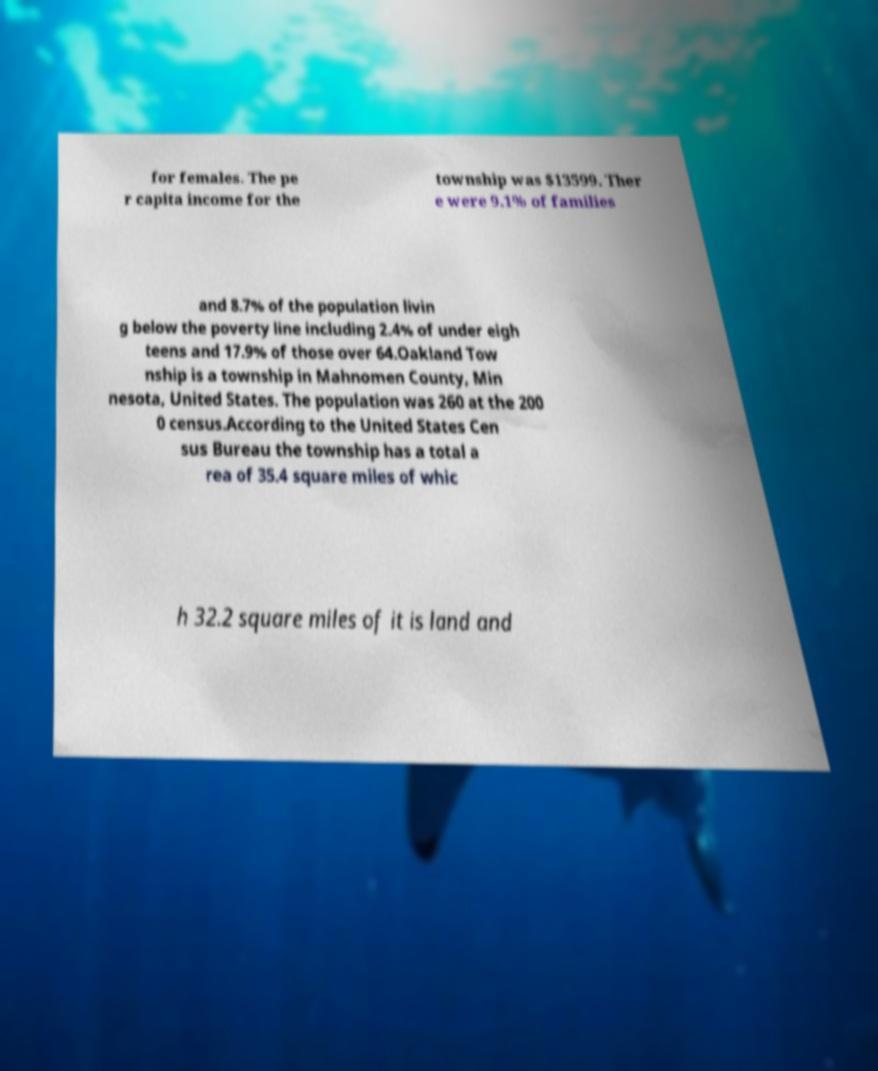Could you extract and type out the text from this image? for females. The pe r capita income for the township was $13599. Ther e were 9.1% of families and 8.7% of the population livin g below the poverty line including 2.4% of under eigh teens and 17.9% of those over 64.Oakland Tow nship is a township in Mahnomen County, Min nesota, United States. The population was 260 at the 200 0 census.According to the United States Cen sus Bureau the township has a total a rea of 35.4 square miles of whic h 32.2 square miles of it is land and 